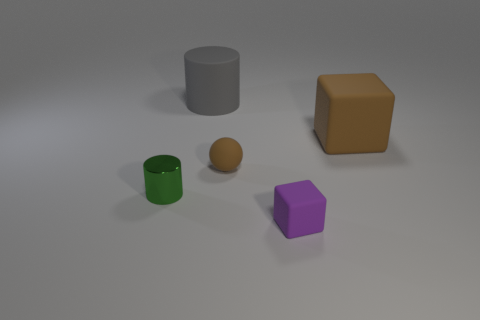How many other things are there of the same color as the small sphere?
Give a very brief answer. 1. What number of purple things have the same material as the brown ball?
Your answer should be very brief. 1. There is a small purple thing; is its shape the same as the big gray matte object that is on the left side of the small brown matte ball?
Make the answer very short. No. There is a matte cube that is in front of the brown rubber object that is on the left side of the brown matte block; is there a big brown cube in front of it?
Make the answer very short. No. There is a thing that is on the left side of the gray cylinder; what size is it?
Provide a short and direct response. Small. What material is the block that is the same size as the gray rubber object?
Ensure brevity in your answer.  Rubber. Does the small brown matte object have the same shape as the large gray thing?
Ensure brevity in your answer.  No. How many objects are gray matte cylinders or brown objects that are left of the big brown rubber thing?
Provide a short and direct response. 2. What material is the large cube that is the same color as the tiny sphere?
Your answer should be compact. Rubber. There is a cylinder to the left of the gray cylinder; does it have the same size as the brown ball?
Your answer should be very brief. Yes. 